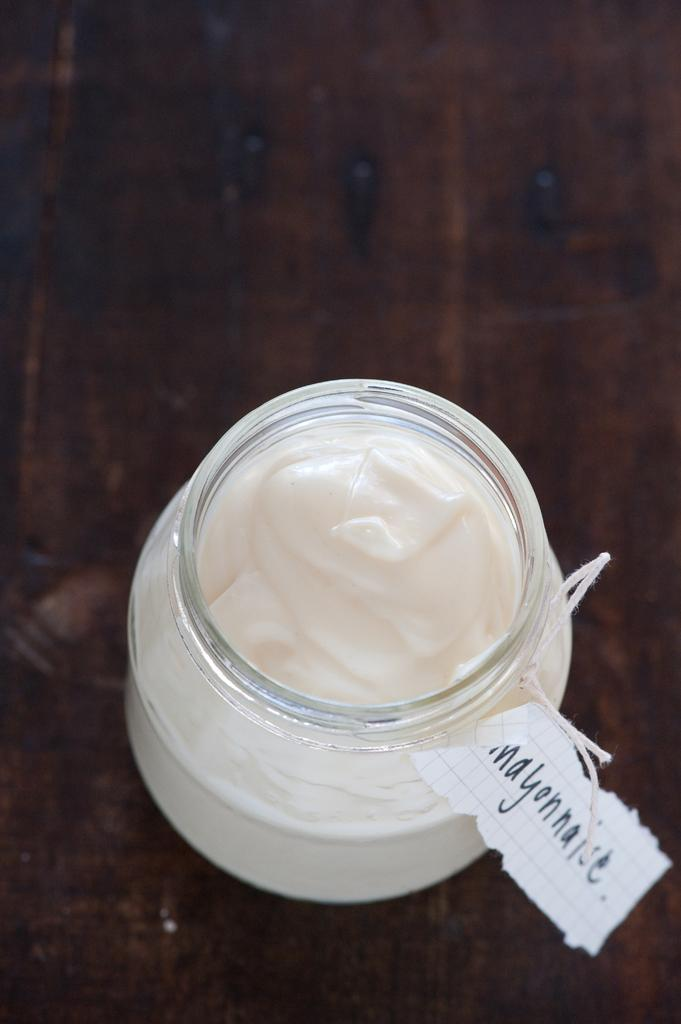Provide a one-sentence caption for the provided image. A jar of labeled mayonnaise on a wooden table. 